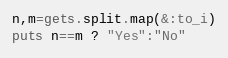<code> <loc_0><loc_0><loc_500><loc_500><_Ruby_>n,m=gets.split.map(&:to_i)
puts n==m ? "Yes":"No"</code> 